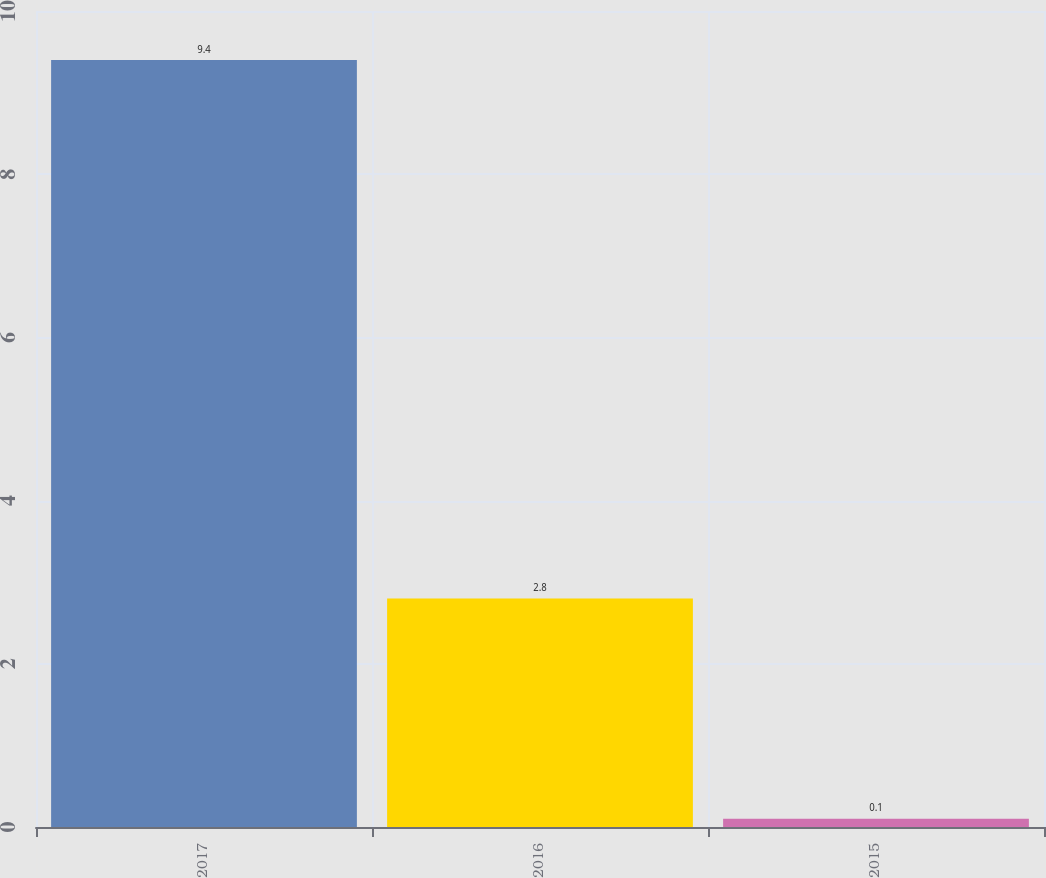Convert chart to OTSL. <chart><loc_0><loc_0><loc_500><loc_500><bar_chart><fcel>2017<fcel>2016<fcel>2015<nl><fcel>9.4<fcel>2.8<fcel>0.1<nl></chart> 